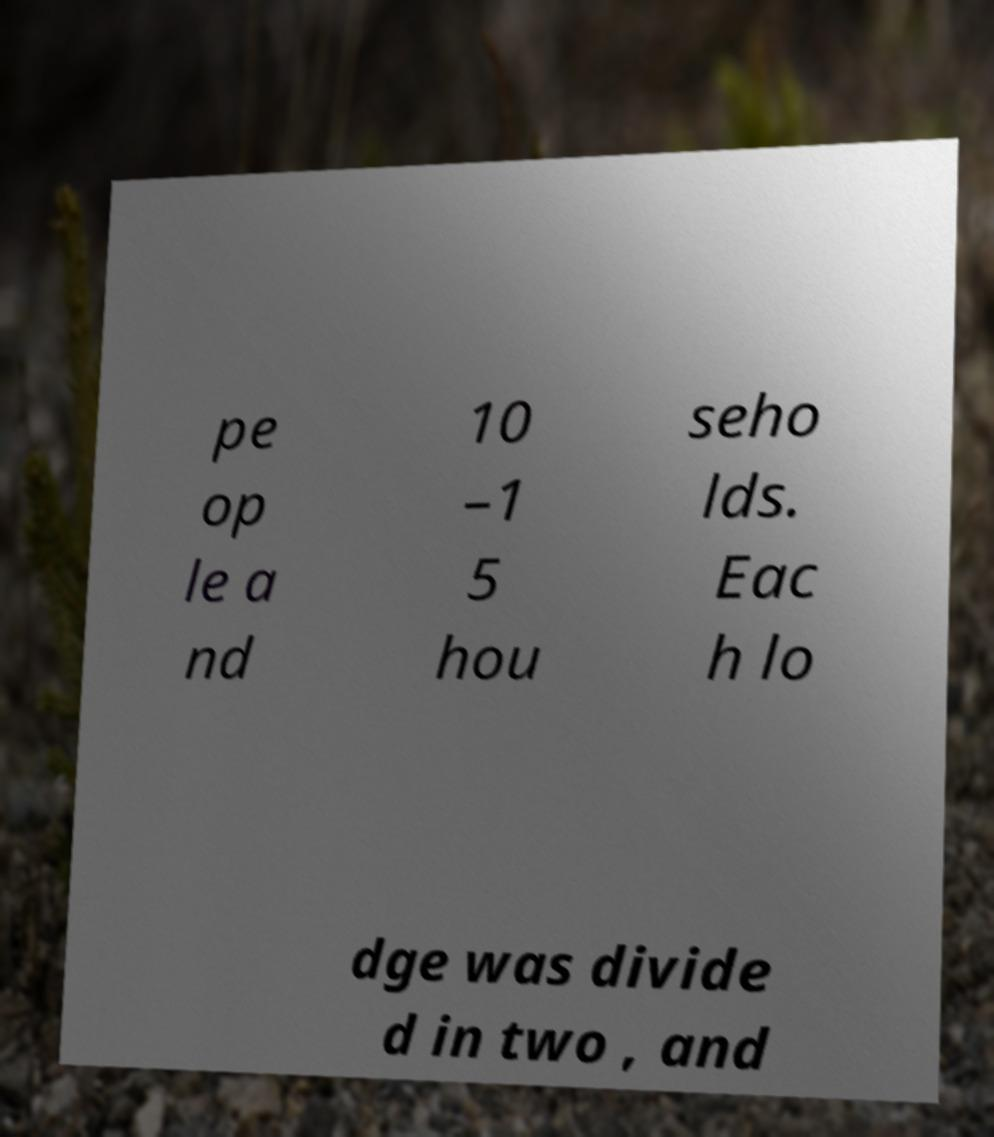Could you extract and type out the text from this image? pe op le a nd 10 –1 5 hou seho lds. Eac h lo dge was divide d in two , and 